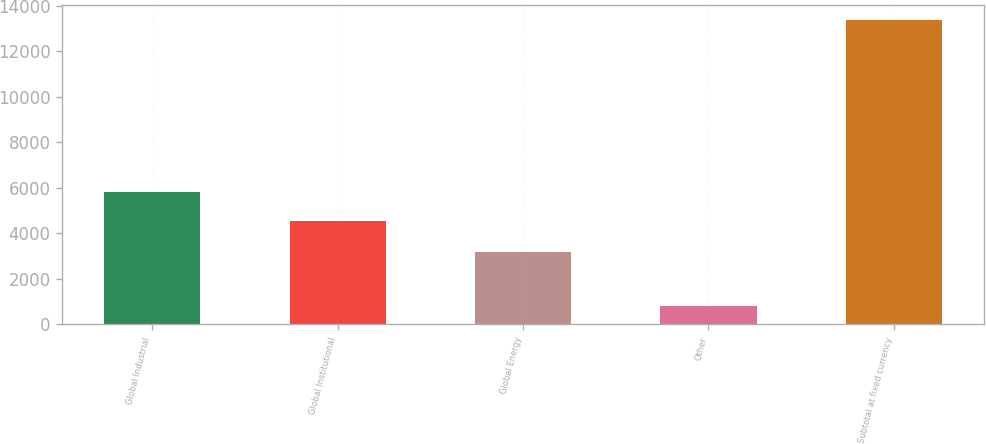<chart> <loc_0><loc_0><loc_500><loc_500><bar_chart><fcel>Global Industrial<fcel>Global Institutional<fcel>Global Energy<fcel>Other<fcel>Subtotal at fixed currency<nl><fcel>5793.46<fcel>4537.5<fcel>3190.3<fcel>821.4<fcel>13381<nl></chart> 